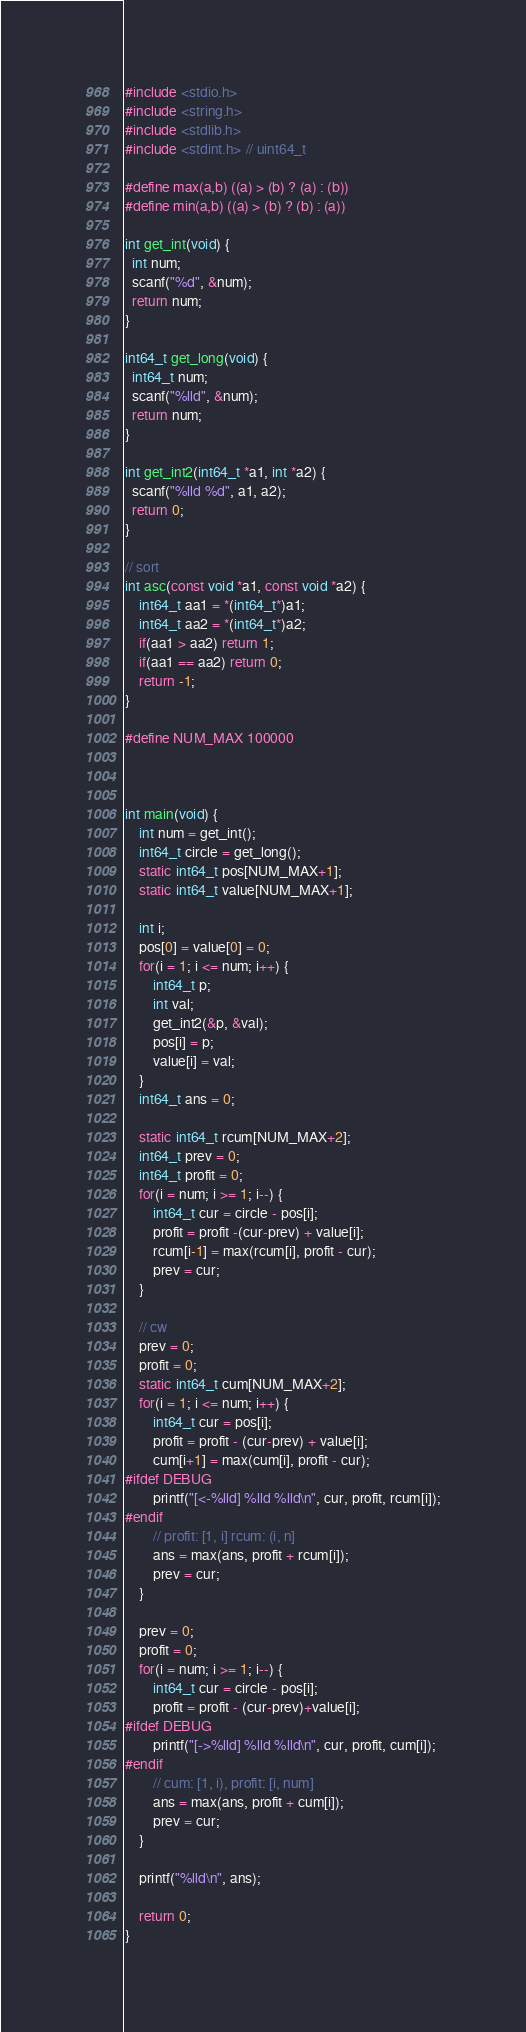Convert code to text. <code><loc_0><loc_0><loc_500><loc_500><_C_>#include <stdio.h>
#include <string.h>
#include <stdlib.h>
#include <stdint.h> // uint64_t

#define max(a,b) ((a) > (b) ? (a) : (b))
#define min(a,b) ((a) > (b) ? (b) : (a))

int get_int(void) {
  int num;
  scanf("%d", &num);
  return num;
}

int64_t get_long(void) {
  int64_t num;
  scanf("%lld", &num);
  return num;
}

int get_int2(int64_t *a1, int *a2) {
  scanf("%lld %d", a1, a2);
  return 0;
}

// sort
int asc(const void *a1, const void *a2) {
    int64_t aa1 = *(int64_t*)a1;
    int64_t aa2 = *(int64_t*)a2;
    if(aa1 > aa2) return 1;
    if(aa1 == aa2) return 0;
    return -1;
}

#define NUM_MAX 100000



int main(void) {
    int num = get_int();
    int64_t circle = get_long();
    static int64_t pos[NUM_MAX+1];
    static int64_t value[NUM_MAX+1];

    int i;
    pos[0] = value[0] = 0;
    for(i = 1; i <= num; i++) {
        int64_t p;
        int val;
        get_int2(&p, &val);
        pos[i] = p;
        value[i] = val;
    }
    int64_t ans = 0;

    static int64_t rcum[NUM_MAX+2];
    int64_t prev = 0;
    int64_t profit = 0;
    for(i = num; i >= 1; i--) {
        int64_t cur = circle - pos[i];
        profit = profit -(cur-prev) + value[i];
        rcum[i-1] = max(rcum[i], profit - cur);
        prev = cur;
    }

    // cw
    prev = 0;
    profit = 0;
    static int64_t cum[NUM_MAX+2];
    for(i = 1; i <= num; i++) {
        int64_t cur = pos[i];
        profit = profit - (cur-prev) + value[i];
        cum[i+1] = max(cum[i], profit - cur);
#ifdef DEBUG
        printf("[<-%lld] %lld %lld\n", cur, profit, rcum[i]);
#endif
        // profit: [1, i] rcum: (i, n]
        ans = max(ans, profit + rcum[i]);
        prev = cur;
    }

    prev = 0;
    profit = 0;
    for(i = num; i >= 1; i--) {
        int64_t cur = circle - pos[i];
        profit = profit - (cur-prev)+value[i];
#ifdef DEBUG
        printf("[->%lld] %lld %lld\n", cur, profit, cum[i]);
#endif
        // cum: [1, i), profit: [i, num]
        ans = max(ans, profit + cum[i]);
        prev = cur;
    }

    printf("%lld\n", ans);

    return 0;
}</code> 